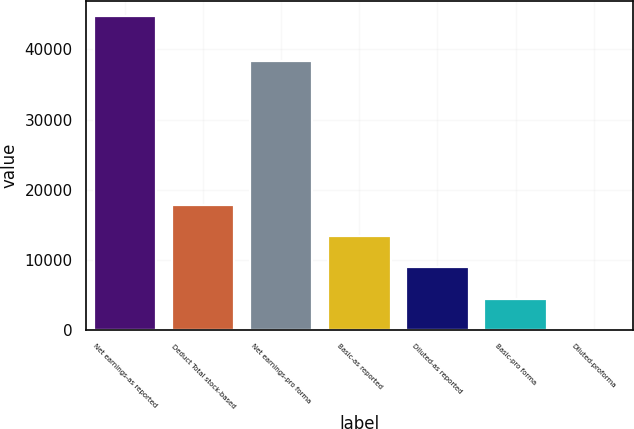<chart> <loc_0><loc_0><loc_500><loc_500><bar_chart><fcel>Net earnings-as reported<fcel>Deduct Total stock-based<fcel>Net earnings-pro forma<fcel>Basic-as reported<fcel>Diluted-as reported<fcel>Basic-pro forma<fcel>Diluted-proforma<nl><fcel>44693<fcel>17877.5<fcel>38365<fcel>13408.3<fcel>8939.04<fcel>4469.79<fcel>0.54<nl></chart> 